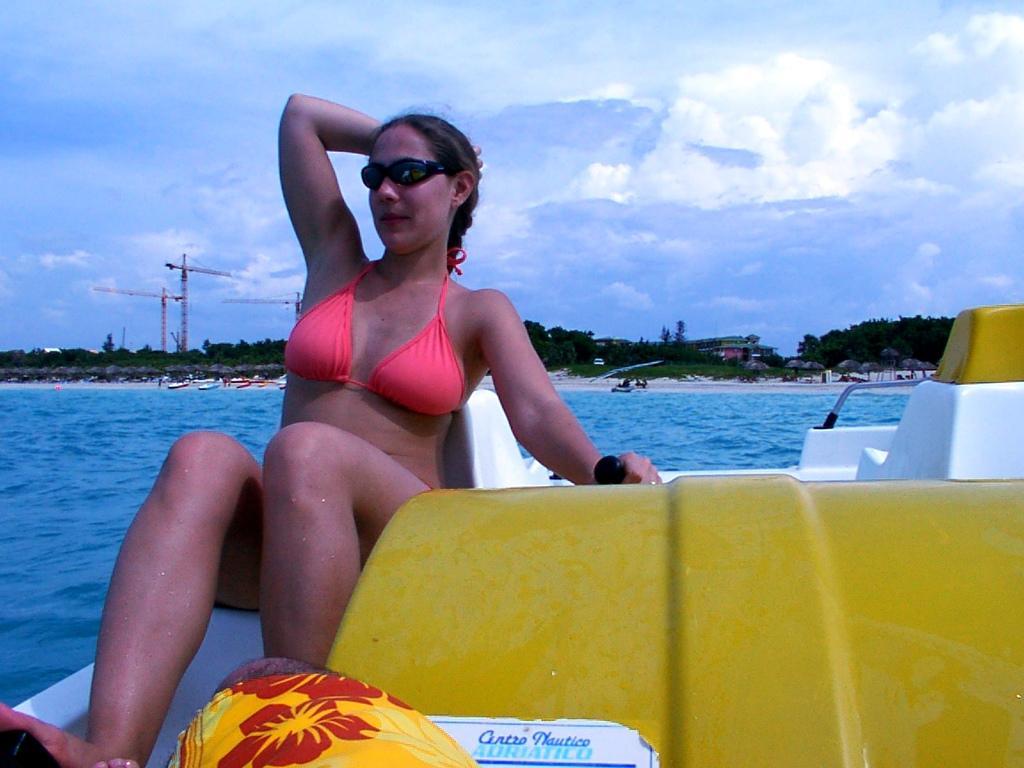Describe this image in one or two sentences. In the image I can see a woman is sitting on a boat. The woman is wearing a bikini and black color glasses. In the background I can see the water, boats on the water, trees, the sky and some other objects. 